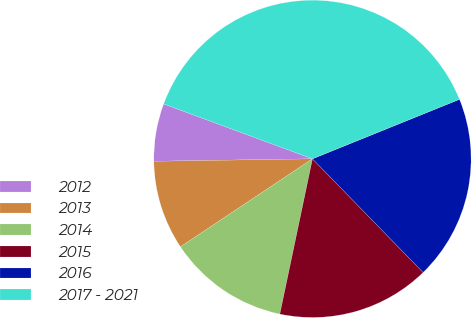Convert chart to OTSL. <chart><loc_0><loc_0><loc_500><loc_500><pie_chart><fcel>2012<fcel>2013<fcel>2014<fcel>2015<fcel>2016<fcel>2017 - 2021<nl><fcel>5.87%<fcel>9.11%<fcel>12.35%<fcel>15.59%<fcel>18.83%<fcel>38.26%<nl></chart> 